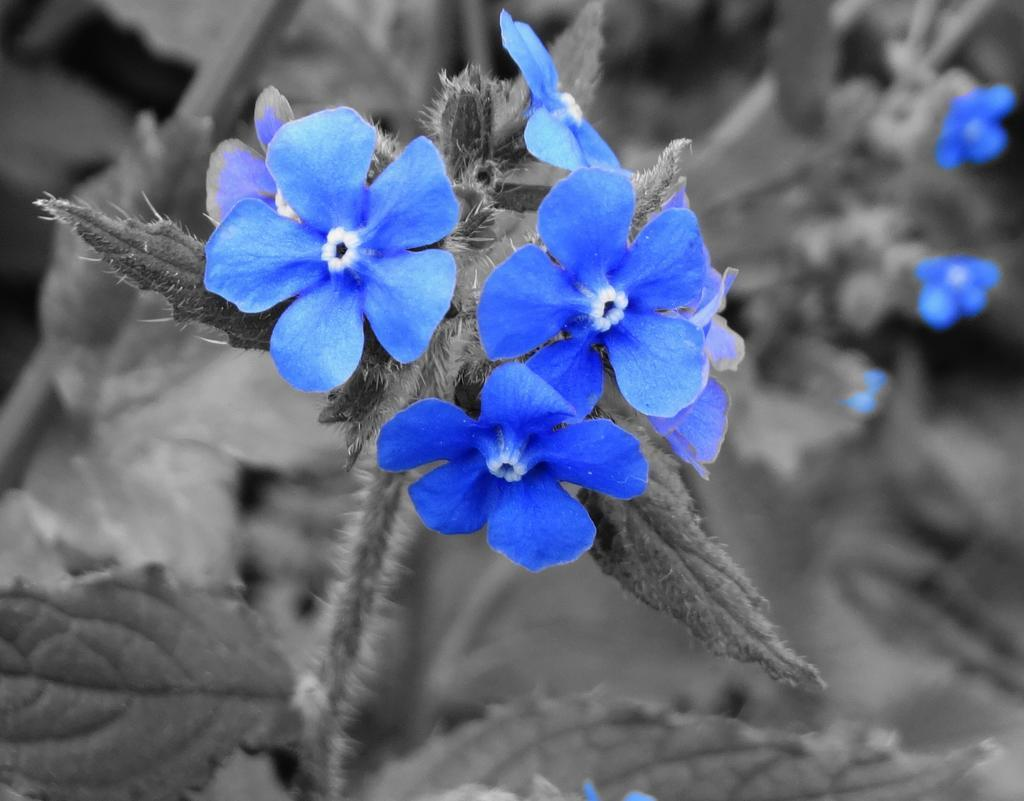What type of plants can be seen in the image? There are plants with flowers in the image. What color are the flowers? The flowers are in blue color. What colors are used for the rest of the image? The remaining parts of the image are in black and white color. What type of meat is being served to the visitor in the image? There is no meat or visitor present in the image; it features plants with blue flowers and a black and white color scheme. 